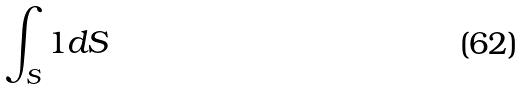Convert formula to latex. <formula><loc_0><loc_0><loc_500><loc_500>\int _ { S } 1 d S</formula> 